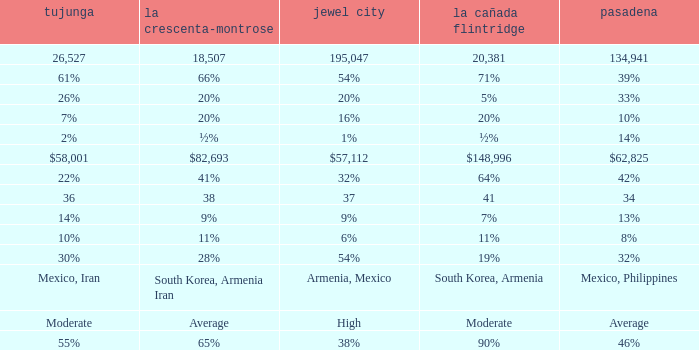What is the percentage of Tujunja when Pasadena is 33%? 26%. 